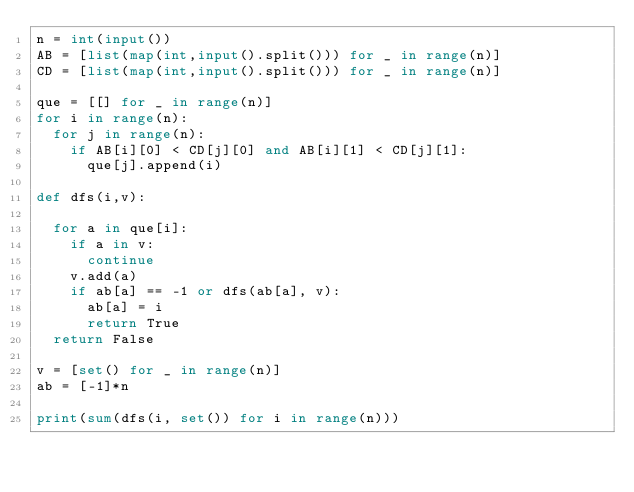Convert code to text. <code><loc_0><loc_0><loc_500><loc_500><_Python_>n = int(input())
AB = [list(map(int,input().split())) for _ in range(n)]
CD = [list(map(int,input().split())) for _ in range(n)]

que = [[] for _ in range(n)]
for i in range(n):
  for j in range(n):
    if AB[i][0] < CD[j][0] and AB[i][1] < CD[j][1]:
      que[j].append(i)

def dfs(i,v):
  
  for a in que[i]:
    if a in v:
      continue
    v.add(a)
    if ab[a] == -1 or dfs(ab[a], v):
      ab[a] = i
      return True
  return False
      
v = [set() for _ in range(n)]   
ab = [-1]*n

print(sum(dfs(i, set()) for i in range(n))) </code> 